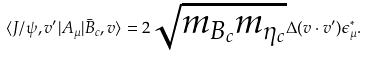Convert formula to latex. <formula><loc_0><loc_0><loc_500><loc_500>\langle J / \psi , v ^ { \prime } | A _ { \mu } | \bar { B } _ { c } , v \rangle = 2 \sqrt { m _ { B _ { c } } m _ { \eta _ { c } } } \Delta ( v \cdot v ^ { \prime } ) \epsilon _ { \mu } ^ { * } .</formula> 